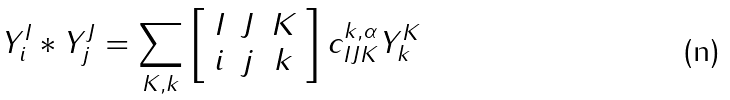<formula> <loc_0><loc_0><loc_500><loc_500>Y ^ { I } _ { i } * Y ^ { J } _ { j } = \sum _ { K , k } \left [ \begin{array} { c c c } I & J & K \\ i & j & k \end{array} \right ] c ^ { k , \alpha } _ { I J K } Y ^ { K } _ { k }</formula> 